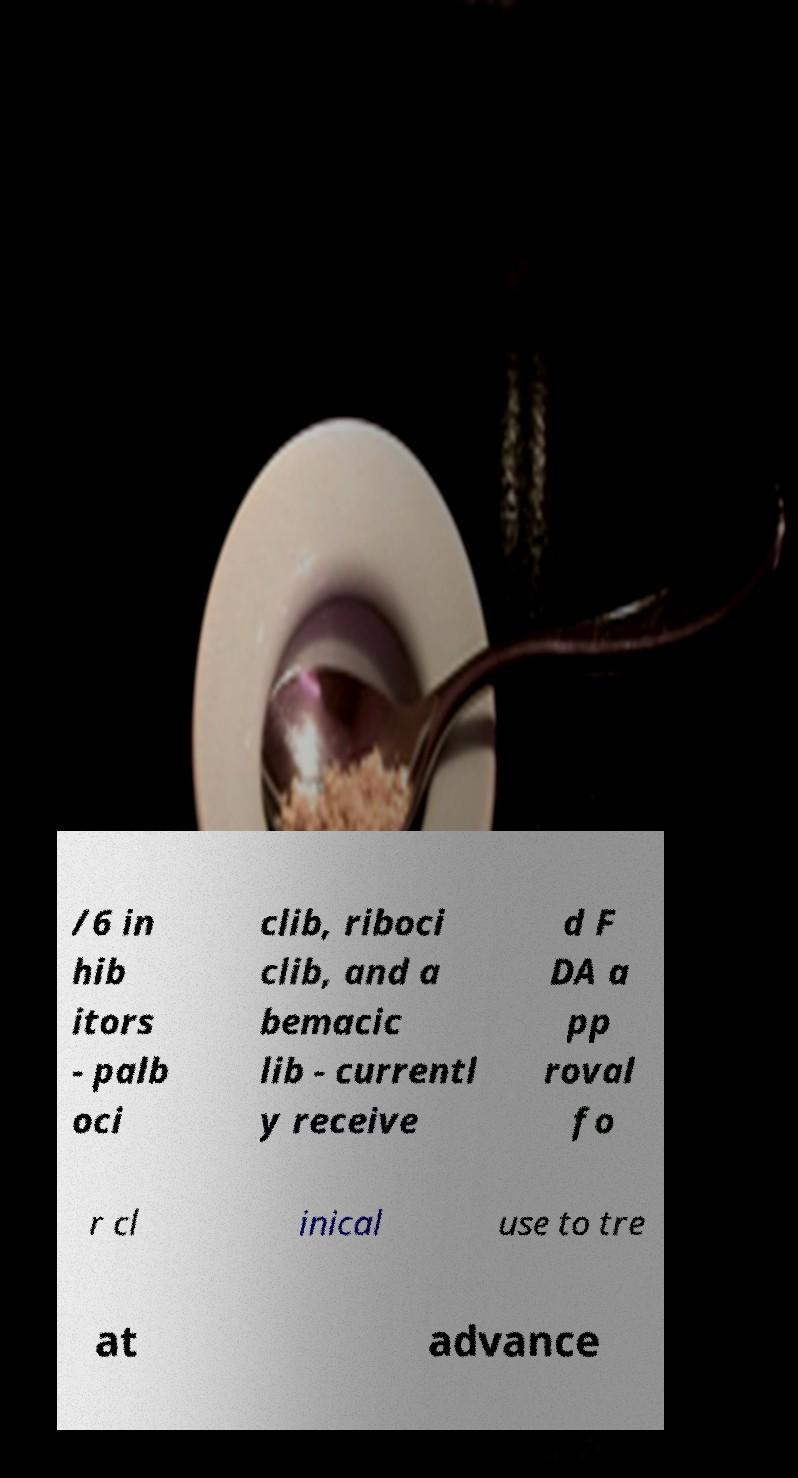What messages or text are displayed in this image? I need them in a readable, typed format. /6 in hib itors - palb oci clib, riboci clib, and a bemacic lib - currentl y receive d F DA a pp roval fo r cl inical use to tre at advance 